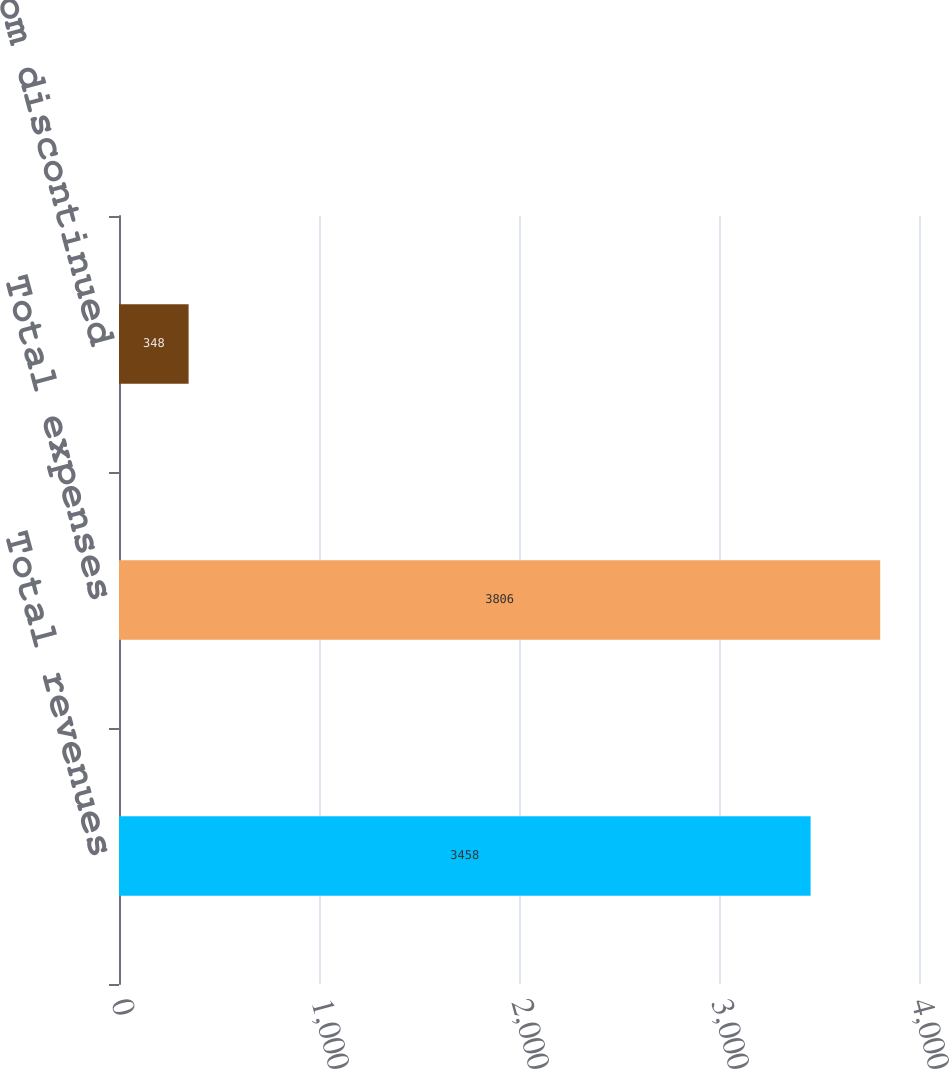Convert chart to OTSL. <chart><loc_0><loc_0><loc_500><loc_500><bar_chart><fcel>Total revenues<fcel>Total expenses<fcel>Loss from discontinued<nl><fcel>3458<fcel>3806<fcel>348<nl></chart> 